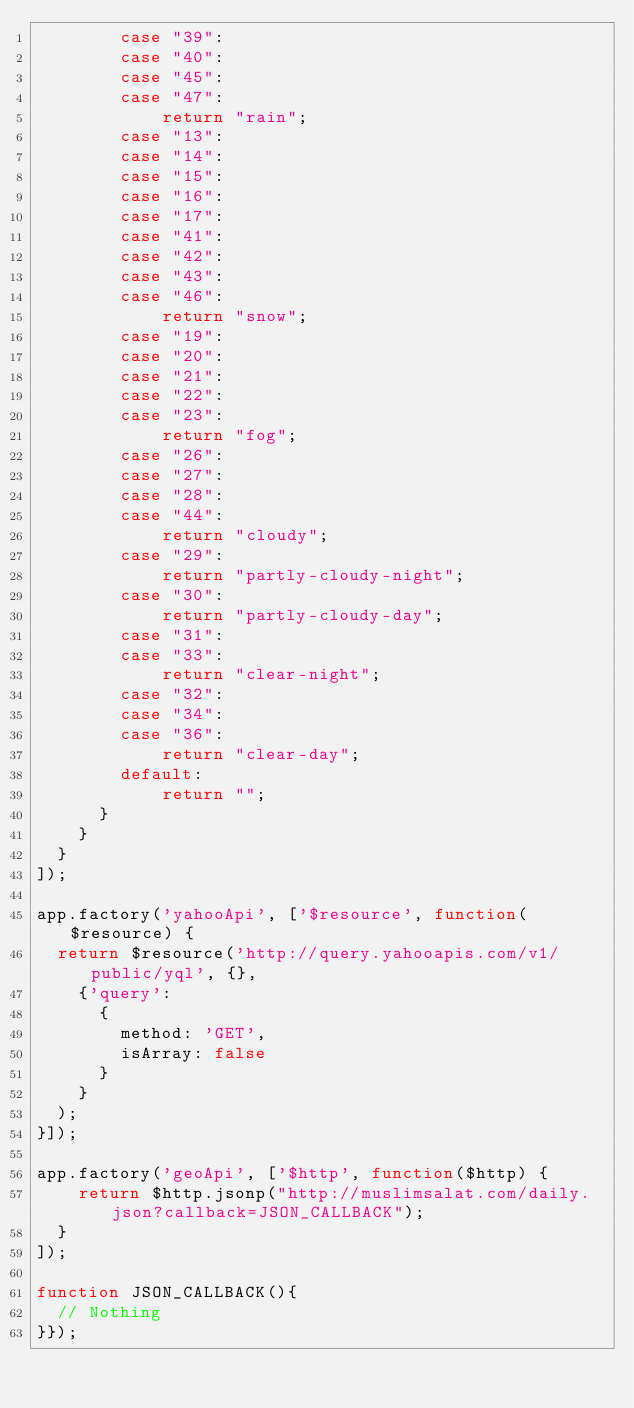Convert code to text. <code><loc_0><loc_0><loc_500><loc_500><_JavaScript_>        case "39":        
        case "40":
        case "45":
        case "47":
            return "rain";
        case "13":
        case "14":
        case "15":
        case "16":
        case "17":
        case "41":
        case "42":
        case "43":
        case "46":
            return "snow";
        case "19":
        case "20":
        case "21":
        case "22":
        case "23":
            return "fog";        
        case "26":
        case "27":
        case "28":
        case "44":
            return "cloudy";
        case "29":
            return "partly-cloudy-night";
        case "30":
            return "partly-cloudy-day";
        case "31":
        case "33":
            return "clear-night";
        case "32":
        case "34":
        case "36":
            return "clear-day";
        default:
            return "";
      }
    }
  }
]);

app.factory('yahooApi', ['$resource', function($resource) {
  return $resource('http://query.yahooapis.com/v1/public/yql', {}, 
    {'query': 
      {
        method: 'GET', 
        isArray: false
      }
    }
  );
}]);

app.factory('geoApi', ['$http', function($http) {
    return $http.jsonp("http://muslimsalat.com/daily.json?callback=JSON_CALLBACK");
  }
]);

function JSON_CALLBACK(){
  // Nothing
}});</code> 